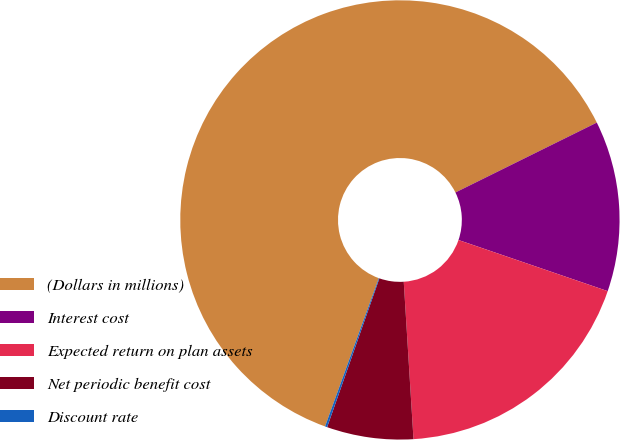Convert chart to OTSL. <chart><loc_0><loc_0><loc_500><loc_500><pie_chart><fcel>(Dollars in millions)<fcel>Interest cost<fcel>Expected return on plan assets<fcel>Net periodic benefit cost<fcel>Discount rate<nl><fcel>62.15%<fcel>12.56%<fcel>18.76%<fcel>6.36%<fcel>0.16%<nl></chart> 